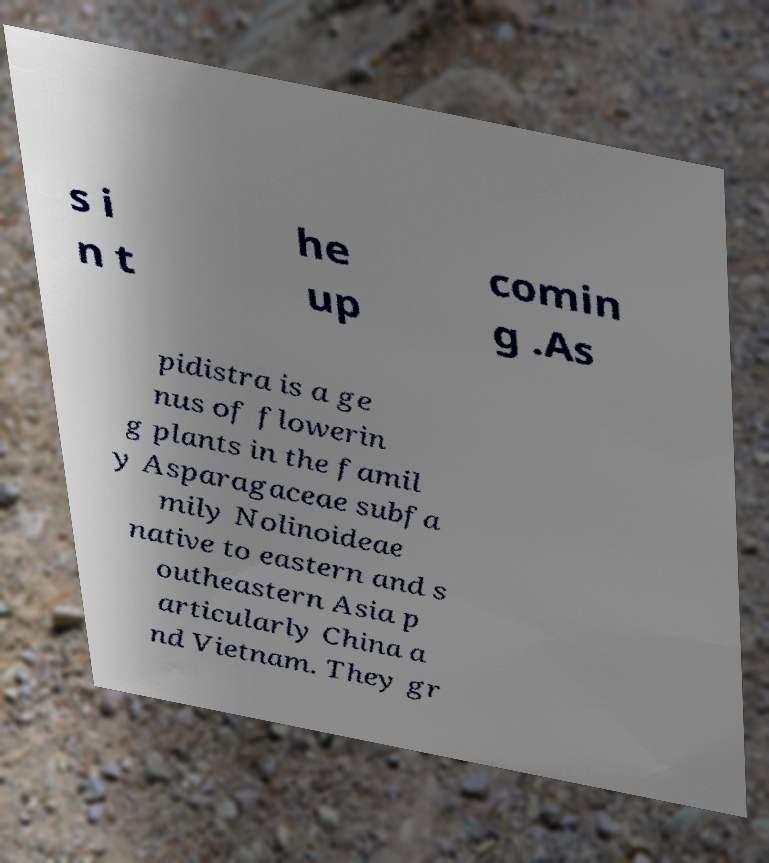I need the written content from this picture converted into text. Can you do that? s i n t he up comin g .As pidistra is a ge nus of flowerin g plants in the famil y Asparagaceae subfa mily Nolinoideae native to eastern and s outheastern Asia p articularly China a nd Vietnam. They gr 